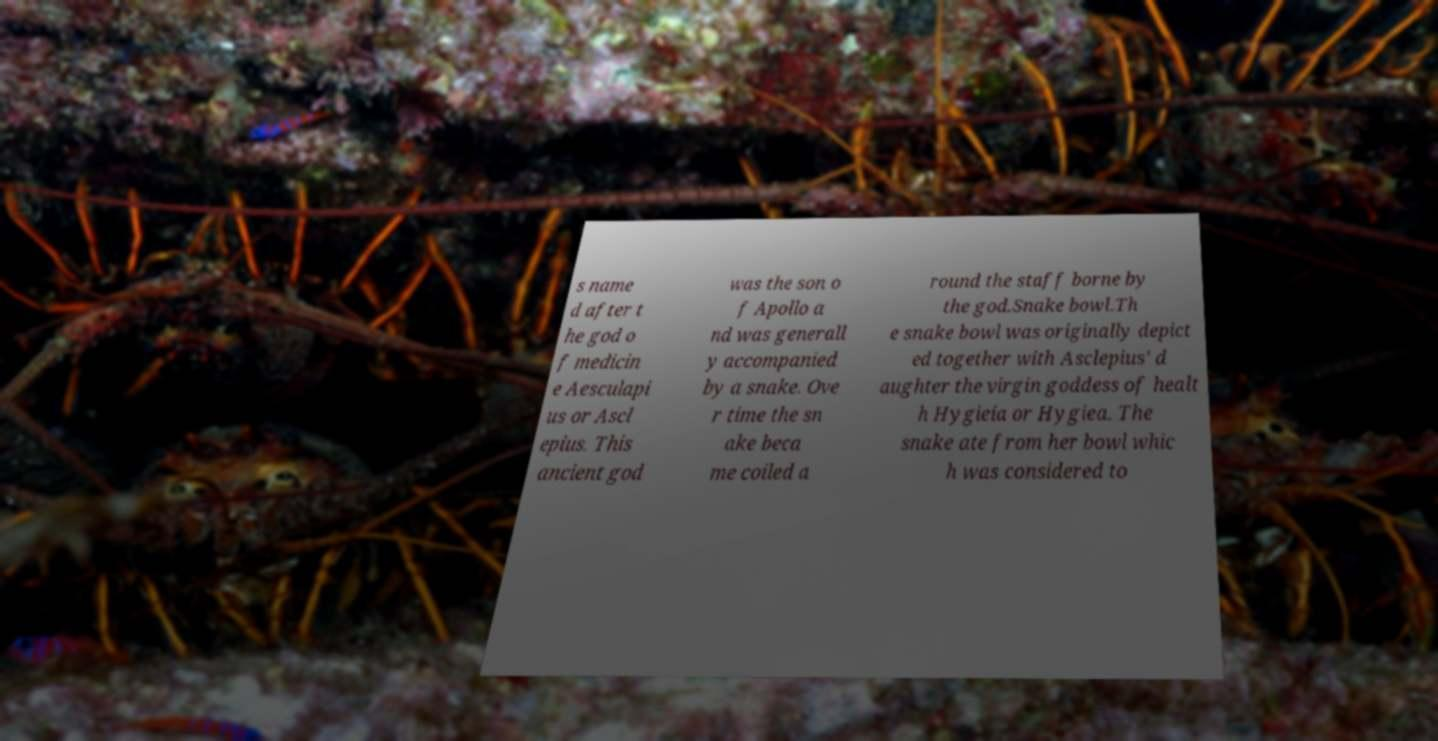Can you accurately transcribe the text from the provided image for me? s name d after t he god o f medicin e Aesculapi us or Ascl epius. This ancient god was the son o f Apollo a nd was generall y accompanied by a snake. Ove r time the sn ake beca me coiled a round the staff borne by the god.Snake bowl.Th e snake bowl was originally depict ed together with Asclepius' d aughter the virgin goddess of healt h Hygieia or Hygiea. The snake ate from her bowl whic h was considered to 